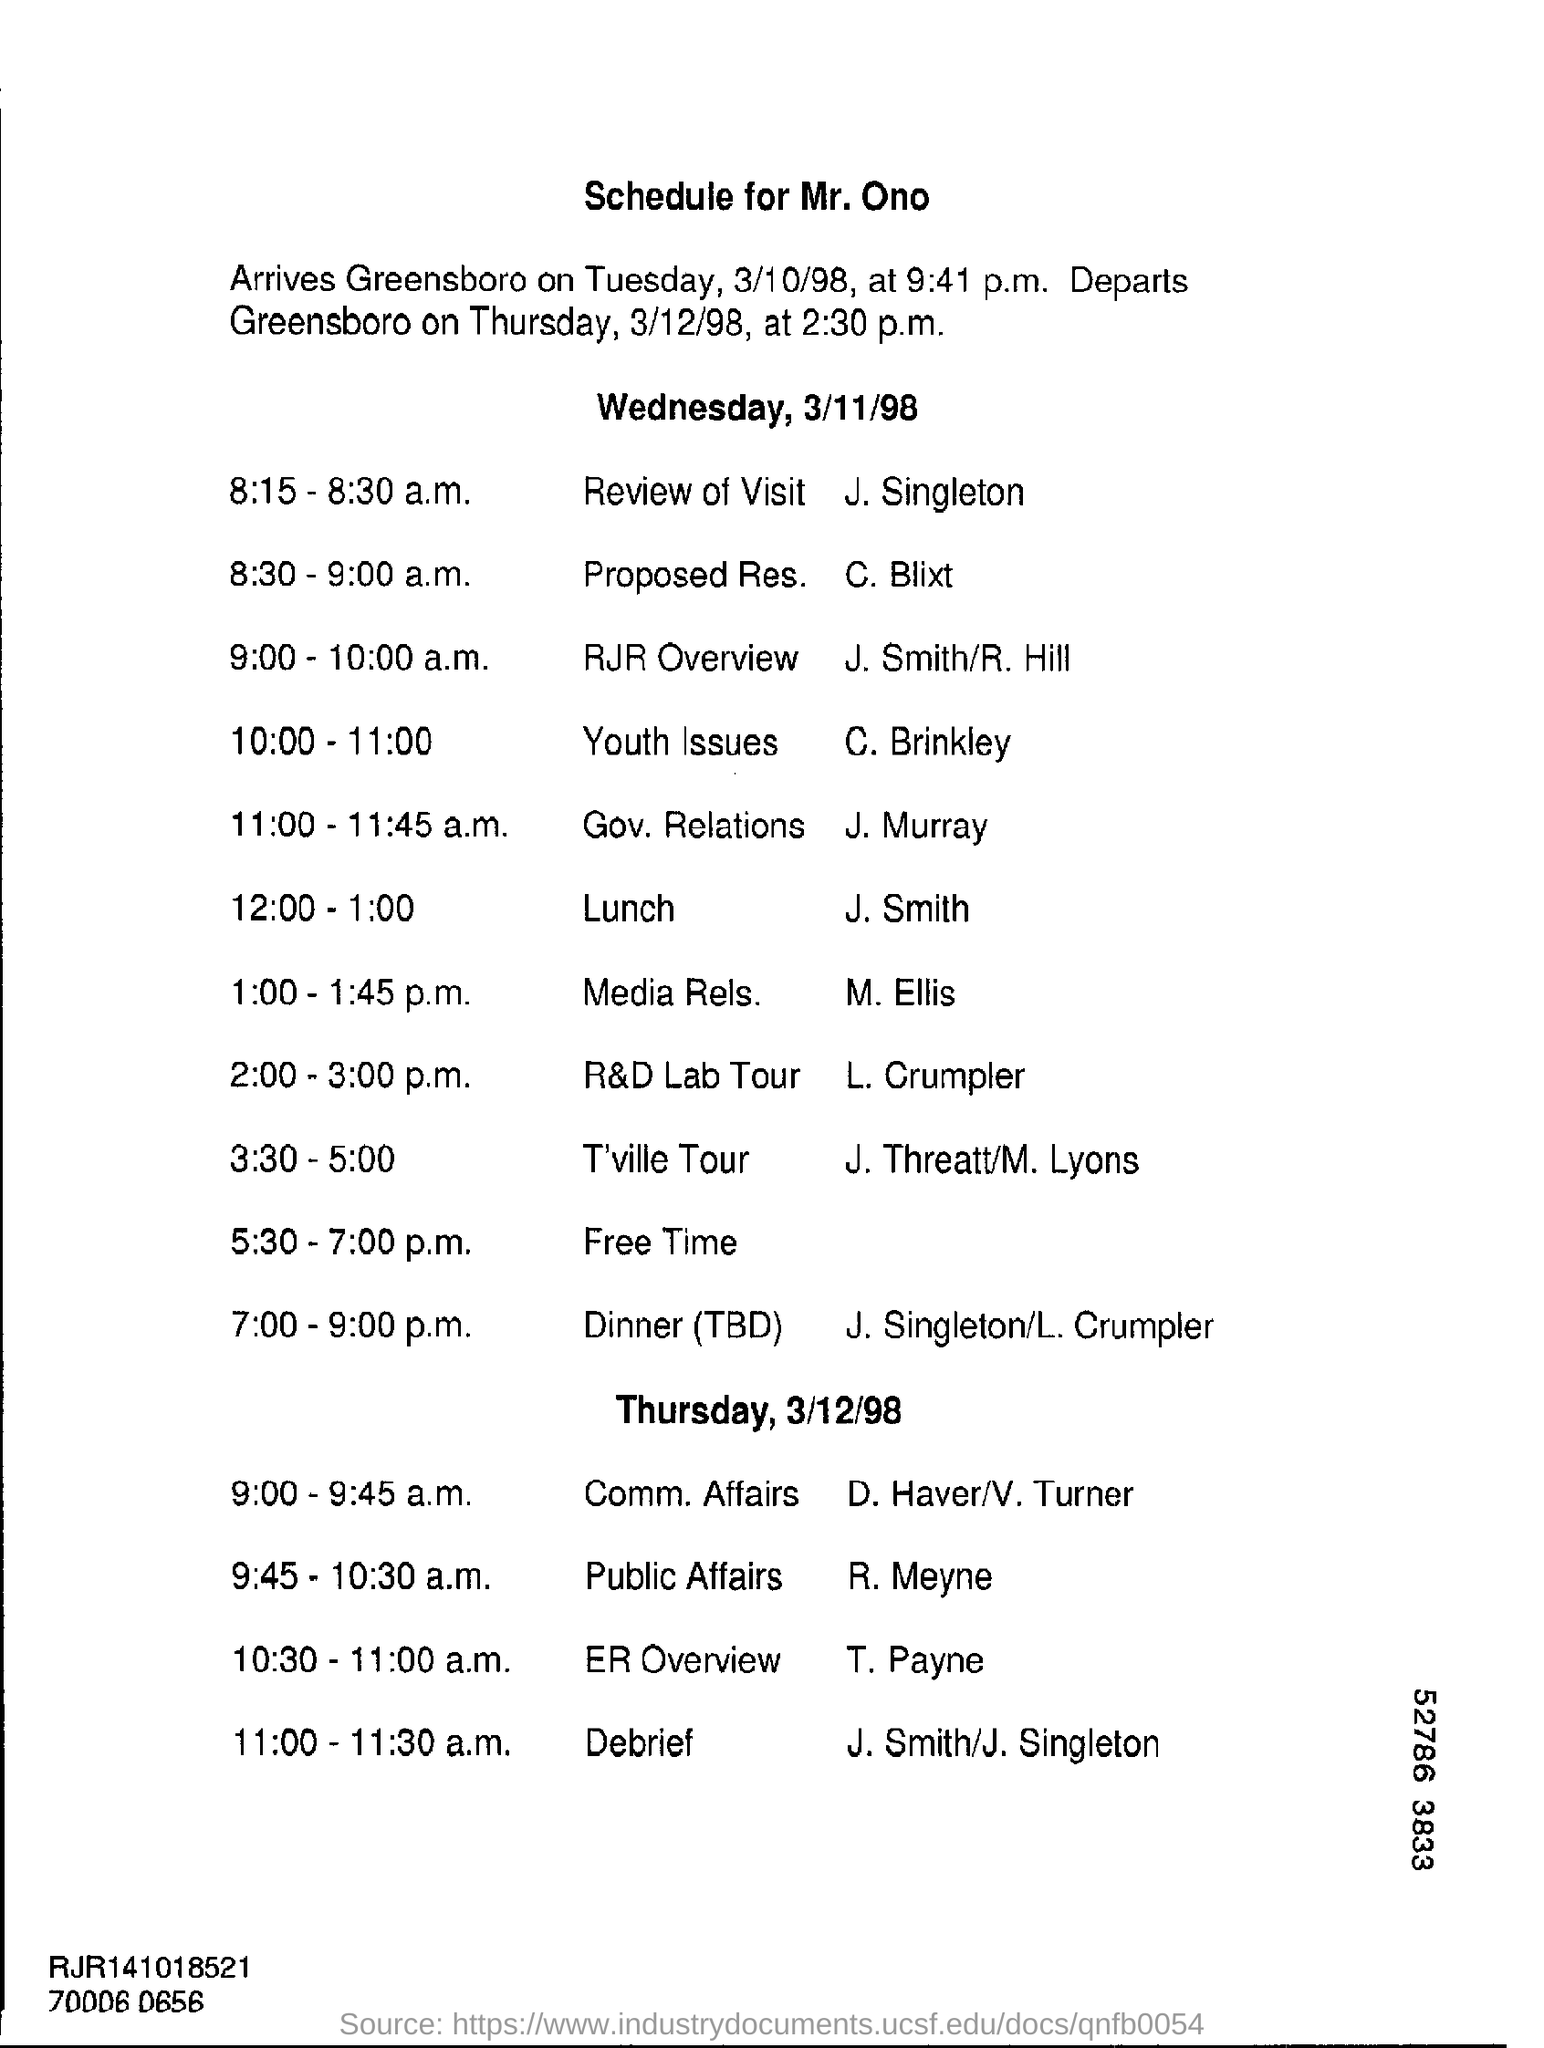Give some essential details in this illustration. On Tuesday, March 10, 1998, Mr. Ono arrived in Greensboro. The review of the visit is scheduled to take place between 8:15-8:30 a.m. This schedule is for Mr. Ono. From 12:00-1:00, lunch will take place. 